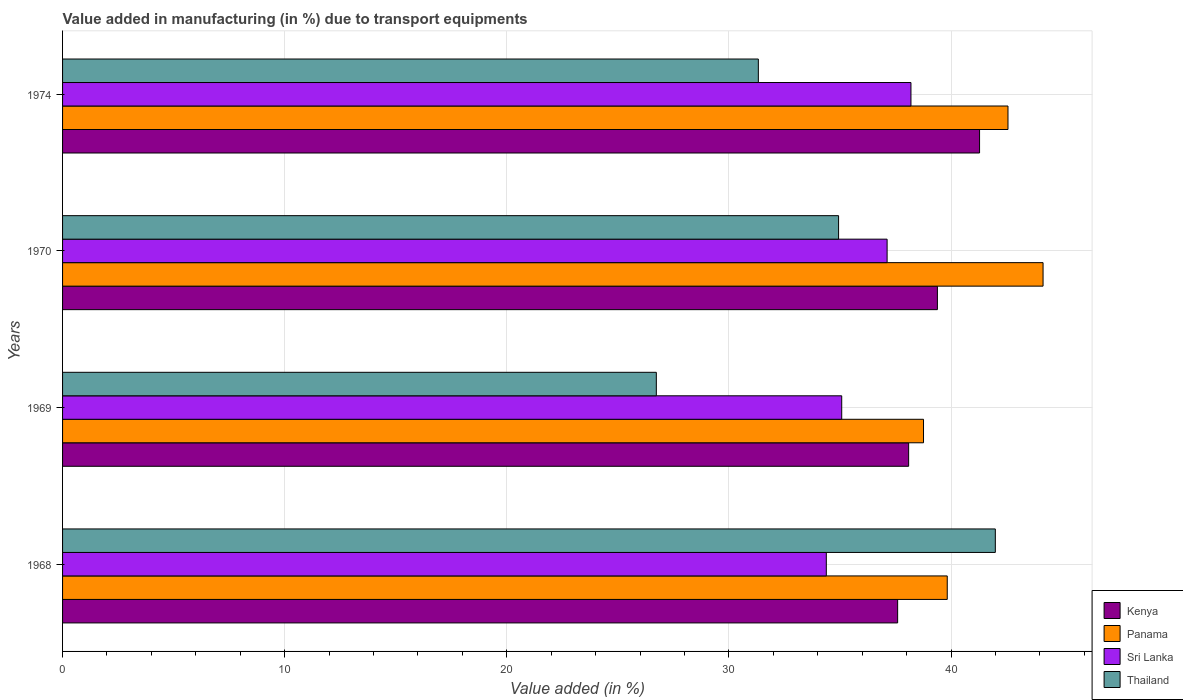How many different coloured bars are there?
Ensure brevity in your answer.  4. Are the number of bars per tick equal to the number of legend labels?
Offer a very short reply. Yes. Are the number of bars on each tick of the Y-axis equal?
Give a very brief answer. Yes. How many bars are there on the 1st tick from the top?
Give a very brief answer. 4. What is the label of the 4th group of bars from the top?
Make the answer very short. 1968. What is the percentage of value added in manufacturing due to transport equipments in Sri Lanka in 1969?
Your answer should be compact. 35.08. Across all years, what is the maximum percentage of value added in manufacturing due to transport equipments in Panama?
Offer a terse response. 44.14. Across all years, what is the minimum percentage of value added in manufacturing due to transport equipments in Thailand?
Keep it short and to the point. 26.73. In which year was the percentage of value added in manufacturing due to transport equipments in Panama maximum?
Offer a terse response. 1970. In which year was the percentage of value added in manufacturing due to transport equipments in Kenya minimum?
Offer a very short reply. 1968. What is the total percentage of value added in manufacturing due to transport equipments in Panama in the graph?
Your answer should be very brief. 165.3. What is the difference between the percentage of value added in manufacturing due to transport equipments in Panama in 1968 and that in 1970?
Give a very brief answer. -4.31. What is the difference between the percentage of value added in manufacturing due to transport equipments in Panama in 1970 and the percentage of value added in manufacturing due to transport equipments in Thailand in 1974?
Give a very brief answer. 12.82. What is the average percentage of value added in manufacturing due to transport equipments in Panama per year?
Your answer should be compact. 41.33. In the year 1969, what is the difference between the percentage of value added in manufacturing due to transport equipments in Sri Lanka and percentage of value added in manufacturing due to transport equipments in Panama?
Your response must be concise. -3.68. In how many years, is the percentage of value added in manufacturing due to transport equipments in Kenya greater than 42 %?
Ensure brevity in your answer.  0. What is the ratio of the percentage of value added in manufacturing due to transport equipments in Kenya in 1968 to that in 1969?
Ensure brevity in your answer.  0.99. Is the percentage of value added in manufacturing due to transport equipments in Kenya in 1970 less than that in 1974?
Your response must be concise. Yes. What is the difference between the highest and the second highest percentage of value added in manufacturing due to transport equipments in Panama?
Make the answer very short. 1.58. What is the difference between the highest and the lowest percentage of value added in manufacturing due to transport equipments in Sri Lanka?
Your answer should be compact. 3.81. In how many years, is the percentage of value added in manufacturing due to transport equipments in Kenya greater than the average percentage of value added in manufacturing due to transport equipments in Kenya taken over all years?
Your response must be concise. 2. Is the sum of the percentage of value added in manufacturing due to transport equipments in Thailand in 1968 and 1970 greater than the maximum percentage of value added in manufacturing due to transport equipments in Sri Lanka across all years?
Offer a very short reply. Yes. What does the 2nd bar from the top in 1970 represents?
Provide a short and direct response. Sri Lanka. What does the 4th bar from the bottom in 1970 represents?
Offer a terse response. Thailand. How many bars are there?
Your answer should be very brief. 16. Are all the bars in the graph horizontal?
Ensure brevity in your answer.  Yes. Does the graph contain any zero values?
Your answer should be compact. No. Where does the legend appear in the graph?
Your answer should be compact. Bottom right. How many legend labels are there?
Make the answer very short. 4. How are the legend labels stacked?
Make the answer very short. Vertical. What is the title of the graph?
Your answer should be very brief. Value added in manufacturing (in %) due to transport equipments. Does "Zimbabwe" appear as one of the legend labels in the graph?
Offer a terse response. No. What is the label or title of the X-axis?
Your answer should be compact. Value added (in %). What is the label or title of the Y-axis?
Your answer should be very brief. Years. What is the Value added (in %) of Kenya in 1968?
Provide a short and direct response. 37.6. What is the Value added (in %) of Panama in 1968?
Ensure brevity in your answer.  39.83. What is the Value added (in %) of Sri Lanka in 1968?
Your answer should be very brief. 34.39. What is the Value added (in %) in Thailand in 1968?
Offer a very short reply. 41.99. What is the Value added (in %) of Kenya in 1969?
Your response must be concise. 38.09. What is the Value added (in %) of Panama in 1969?
Your answer should be compact. 38.76. What is the Value added (in %) of Sri Lanka in 1969?
Ensure brevity in your answer.  35.08. What is the Value added (in %) in Thailand in 1969?
Give a very brief answer. 26.73. What is the Value added (in %) of Kenya in 1970?
Offer a very short reply. 39.39. What is the Value added (in %) in Panama in 1970?
Offer a terse response. 44.14. What is the Value added (in %) of Sri Lanka in 1970?
Give a very brief answer. 37.12. What is the Value added (in %) of Thailand in 1970?
Your answer should be very brief. 34.94. What is the Value added (in %) of Kenya in 1974?
Provide a short and direct response. 41.29. What is the Value added (in %) of Panama in 1974?
Provide a short and direct response. 42.56. What is the Value added (in %) of Sri Lanka in 1974?
Offer a very short reply. 38.2. What is the Value added (in %) of Thailand in 1974?
Your answer should be very brief. 31.33. Across all years, what is the maximum Value added (in %) in Kenya?
Keep it short and to the point. 41.29. Across all years, what is the maximum Value added (in %) of Panama?
Offer a very short reply. 44.14. Across all years, what is the maximum Value added (in %) of Sri Lanka?
Offer a very short reply. 38.2. Across all years, what is the maximum Value added (in %) in Thailand?
Ensure brevity in your answer.  41.99. Across all years, what is the minimum Value added (in %) in Kenya?
Provide a succinct answer. 37.6. Across all years, what is the minimum Value added (in %) of Panama?
Ensure brevity in your answer.  38.76. Across all years, what is the minimum Value added (in %) of Sri Lanka?
Ensure brevity in your answer.  34.39. Across all years, what is the minimum Value added (in %) of Thailand?
Offer a terse response. 26.73. What is the total Value added (in %) of Kenya in the graph?
Your response must be concise. 156.36. What is the total Value added (in %) in Panama in the graph?
Offer a very short reply. 165.3. What is the total Value added (in %) of Sri Lanka in the graph?
Make the answer very short. 144.78. What is the total Value added (in %) in Thailand in the graph?
Offer a very short reply. 134.99. What is the difference between the Value added (in %) in Kenya in 1968 and that in 1969?
Your response must be concise. -0.49. What is the difference between the Value added (in %) in Panama in 1968 and that in 1969?
Your answer should be very brief. 1.07. What is the difference between the Value added (in %) of Sri Lanka in 1968 and that in 1969?
Give a very brief answer. -0.69. What is the difference between the Value added (in %) in Thailand in 1968 and that in 1969?
Your answer should be very brief. 15.26. What is the difference between the Value added (in %) of Kenya in 1968 and that in 1970?
Ensure brevity in your answer.  -1.79. What is the difference between the Value added (in %) of Panama in 1968 and that in 1970?
Provide a succinct answer. -4.31. What is the difference between the Value added (in %) in Sri Lanka in 1968 and that in 1970?
Your answer should be very brief. -2.74. What is the difference between the Value added (in %) in Thailand in 1968 and that in 1970?
Your response must be concise. 7.06. What is the difference between the Value added (in %) of Kenya in 1968 and that in 1974?
Give a very brief answer. -3.69. What is the difference between the Value added (in %) in Panama in 1968 and that in 1974?
Your answer should be very brief. -2.73. What is the difference between the Value added (in %) in Sri Lanka in 1968 and that in 1974?
Your response must be concise. -3.81. What is the difference between the Value added (in %) of Thailand in 1968 and that in 1974?
Offer a terse response. 10.67. What is the difference between the Value added (in %) of Kenya in 1969 and that in 1970?
Ensure brevity in your answer.  -1.3. What is the difference between the Value added (in %) of Panama in 1969 and that in 1970?
Give a very brief answer. -5.38. What is the difference between the Value added (in %) of Sri Lanka in 1969 and that in 1970?
Provide a succinct answer. -2.04. What is the difference between the Value added (in %) in Thailand in 1969 and that in 1970?
Ensure brevity in your answer.  -8.21. What is the difference between the Value added (in %) of Kenya in 1969 and that in 1974?
Make the answer very short. -3.19. What is the difference between the Value added (in %) of Panama in 1969 and that in 1974?
Ensure brevity in your answer.  -3.8. What is the difference between the Value added (in %) in Sri Lanka in 1969 and that in 1974?
Your answer should be very brief. -3.12. What is the difference between the Value added (in %) of Thailand in 1969 and that in 1974?
Provide a short and direct response. -4.59. What is the difference between the Value added (in %) of Kenya in 1970 and that in 1974?
Offer a very short reply. -1.9. What is the difference between the Value added (in %) in Panama in 1970 and that in 1974?
Offer a terse response. 1.58. What is the difference between the Value added (in %) in Sri Lanka in 1970 and that in 1974?
Make the answer very short. -1.07. What is the difference between the Value added (in %) in Thailand in 1970 and that in 1974?
Your response must be concise. 3.61. What is the difference between the Value added (in %) in Kenya in 1968 and the Value added (in %) in Panama in 1969?
Give a very brief answer. -1.16. What is the difference between the Value added (in %) in Kenya in 1968 and the Value added (in %) in Sri Lanka in 1969?
Keep it short and to the point. 2.52. What is the difference between the Value added (in %) in Kenya in 1968 and the Value added (in %) in Thailand in 1969?
Your answer should be compact. 10.87. What is the difference between the Value added (in %) in Panama in 1968 and the Value added (in %) in Sri Lanka in 1969?
Keep it short and to the point. 4.75. What is the difference between the Value added (in %) in Panama in 1968 and the Value added (in %) in Thailand in 1969?
Provide a short and direct response. 13.1. What is the difference between the Value added (in %) in Sri Lanka in 1968 and the Value added (in %) in Thailand in 1969?
Provide a short and direct response. 7.65. What is the difference between the Value added (in %) in Kenya in 1968 and the Value added (in %) in Panama in 1970?
Keep it short and to the point. -6.55. What is the difference between the Value added (in %) in Kenya in 1968 and the Value added (in %) in Sri Lanka in 1970?
Offer a very short reply. 0.47. What is the difference between the Value added (in %) of Kenya in 1968 and the Value added (in %) of Thailand in 1970?
Offer a very short reply. 2.66. What is the difference between the Value added (in %) of Panama in 1968 and the Value added (in %) of Sri Lanka in 1970?
Your response must be concise. 2.71. What is the difference between the Value added (in %) in Panama in 1968 and the Value added (in %) in Thailand in 1970?
Provide a short and direct response. 4.89. What is the difference between the Value added (in %) of Sri Lanka in 1968 and the Value added (in %) of Thailand in 1970?
Offer a terse response. -0.55. What is the difference between the Value added (in %) in Kenya in 1968 and the Value added (in %) in Panama in 1974?
Give a very brief answer. -4.97. What is the difference between the Value added (in %) in Kenya in 1968 and the Value added (in %) in Sri Lanka in 1974?
Make the answer very short. -0.6. What is the difference between the Value added (in %) of Kenya in 1968 and the Value added (in %) of Thailand in 1974?
Keep it short and to the point. 6.27. What is the difference between the Value added (in %) in Panama in 1968 and the Value added (in %) in Sri Lanka in 1974?
Provide a succinct answer. 1.63. What is the difference between the Value added (in %) of Panama in 1968 and the Value added (in %) of Thailand in 1974?
Ensure brevity in your answer.  8.51. What is the difference between the Value added (in %) in Sri Lanka in 1968 and the Value added (in %) in Thailand in 1974?
Your response must be concise. 3.06. What is the difference between the Value added (in %) of Kenya in 1969 and the Value added (in %) of Panama in 1970?
Your answer should be compact. -6.05. What is the difference between the Value added (in %) of Kenya in 1969 and the Value added (in %) of Sri Lanka in 1970?
Offer a terse response. 0.97. What is the difference between the Value added (in %) of Kenya in 1969 and the Value added (in %) of Thailand in 1970?
Give a very brief answer. 3.15. What is the difference between the Value added (in %) of Panama in 1969 and the Value added (in %) of Sri Lanka in 1970?
Your answer should be compact. 1.64. What is the difference between the Value added (in %) of Panama in 1969 and the Value added (in %) of Thailand in 1970?
Provide a short and direct response. 3.82. What is the difference between the Value added (in %) of Sri Lanka in 1969 and the Value added (in %) of Thailand in 1970?
Your response must be concise. 0.14. What is the difference between the Value added (in %) in Kenya in 1969 and the Value added (in %) in Panama in 1974?
Ensure brevity in your answer.  -4.47. What is the difference between the Value added (in %) in Kenya in 1969 and the Value added (in %) in Sri Lanka in 1974?
Offer a terse response. -0.1. What is the difference between the Value added (in %) of Kenya in 1969 and the Value added (in %) of Thailand in 1974?
Your answer should be very brief. 6.77. What is the difference between the Value added (in %) of Panama in 1969 and the Value added (in %) of Sri Lanka in 1974?
Offer a terse response. 0.57. What is the difference between the Value added (in %) in Panama in 1969 and the Value added (in %) in Thailand in 1974?
Your response must be concise. 7.44. What is the difference between the Value added (in %) in Sri Lanka in 1969 and the Value added (in %) in Thailand in 1974?
Your answer should be very brief. 3.75. What is the difference between the Value added (in %) in Kenya in 1970 and the Value added (in %) in Panama in 1974?
Ensure brevity in your answer.  -3.18. What is the difference between the Value added (in %) in Kenya in 1970 and the Value added (in %) in Sri Lanka in 1974?
Make the answer very short. 1.19. What is the difference between the Value added (in %) of Kenya in 1970 and the Value added (in %) of Thailand in 1974?
Provide a succinct answer. 8.06. What is the difference between the Value added (in %) of Panama in 1970 and the Value added (in %) of Sri Lanka in 1974?
Provide a succinct answer. 5.95. What is the difference between the Value added (in %) of Panama in 1970 and the Value added (in %) of Thailand in 1974?
Your answer should be compact. 12.82. What is the difference between the Value added (in %) of Sri Lanka in 1970 and the Value added (in %) of Thailand in 1974?
Offer a very short reply. 5.8. What is the average Value added (in %) of Kenya per year?
Make the answer very short. 39.09. What is the average Value added (in %) of Panama per year?
Your answer should be compact. 41.33. What is the average Value added (in %) of Sri Lanka per year?
Your response must be concise. 36.2. What is the average Value added (in %) in Thailand per year?
Keep it short and to the point. 33.75. In the year 1968, what is the difference between the Value added (in %) in Kenya and Value added (in %) in Panama?
Your answer should be very brief. -2.23. In the year 1968, what is the difference between the Value added (in %) in Kenya and Value added (in %) in Sri Lanka?
Ensure brevity in your answer.  3.21. In the year 1968, what is the difference between the Value added (in %) of Kenya and Value added (in %) of Thailand?
Ensure brevity in your answer.  -4.4. In the year 1968, what is the difference between the Value added (in %) of Panama and Value added (in %) of Sri Lanka?
Make the answer very short. 5.45. In the year 1968, what is the difference between the Value added (in %) of Panama and Value added (in %) of Thailand?
Provide a short and direct response. -2.16. In the year 1968, what is the difference between the Value added (in %) of Sri Lanka and Value added (in %) of Thailand?
Offer a very short reply. -7.61. In the year 1969, what is the difference between the Value added (in %) in Kenya and Value added (in %) in Panama?
Provide a succinct answer. -0.67. In the year 1969, what is the difference between the Value added (in %) of Kenya and Value added (in %) of Sri Lanka?
Offer a terse response. 3.01. In the year 1969, what is the difference between the Value added (in %) in Kenya and Value added (in %) in Thailand?
Your response must be concise. 11.36. In the year 1969, what is the difference between the Value added (in %) of Panama and Value added (in %) of Sri Lanka?
Your answer should be compact. 3.68. In the year 1969, what is the difference between the Value added (in %) of Panama and Value added (in %) of Thailand?
Give a very brief answer. 12.03. In the year 1969, what is the difference between the Value added (in %) in Sri Lanka and Value added (in %) in Thailand?
Offer a terse response. 8.35. In the year 1970, what is the difference between the Value added (in %) in Kenya and Value added (in %) in Panama?
Provide a short and direct response. -4.76. In the year 1970, what is the difference between the Value added (in %) of Kenya and Value added (in %) of Sri Lanka?
Offer a very short reply. 2.26. In the year 1970, what is the difference between the Value added (in %) in Kenya and Value added (in %) in Thailand?
Provide a short and direct response. 4.45. In the year 1970, what is the difference between the Value added (in %) of Panama and Value added (in %) of Sri Lanka?
Your response must be concise. 7.02. In the year 1970, what is the difference between the Value added (in %) of Panama and Value added (in %) of Thailand?
Your response must be concise. 9.21. In the year 1970, what is the difference between the Value added (in %) in Sri Lanka and Value added (in %) in Thailand?
Provide a short and direct response. 2.19. In the year 1974, what is the difference between the Value added (in %) in Kenya and Value added (in %) in Panama?
Make the answer very short. -1.28. In the year 1974, what is the difference between the Value added (in %) in Kenya and Value added (in %) in Sri Lanka?
Offer a terse response. 3.09. In the year 1974, what is the difference between the Value added (in %) of Kenya and Value added (in %) of Thailand?
Provide a short and direct response. 9.96. In the year 1974, what is the difference between the Value added (in %) in Panama and Value added (in %) in Sri Lanka?
Your answer should be compact. 4.37. In the year 1974, what is the difference between the Value added (in %) in Panama and Value added (in %) in Thailand?
Ensure brevity in your answer.  11.24. In the year 1974, what is the difference between the Value added (in %) in Sri Lanka and Value added (in %) in Thailand?
Make the answer very short. 6.87. What is the ratio of the Value added (in %) in Panama in 1968 to that in 1969?
Keep it short and to the point. 1.03. What is the ratio of the Value added (in %) of Sri Lanka in 1968 to that in 1969?
Give a very brief answer. 0.98. What is the ratio of the Value added (in %) of Thailand in 1968 to that in 1969?
Give a very brief answer. 1.57. What is the ratio of the Value added (in %) of Kenya in 1968 to that in 1970?
Give a very brief answer. 0.95. What is the ratio of the Value added (in %) of Panama in 1968 to that in 1970?
Your answer should be very brief. 0.9. What is the ratio of the Value added (in %) of Sri Lanka in 1968 to that in 1970?
Make the answer very short. 0.93. What is the ratio of the Value added (in %) of Thailand in 1968 to that in 1970?
Provide a succinct answer. 1.2. What is the ratio of the Value added (in %) of Kenya in 1968 to that in 1974?
Your answer should be compact. 0.91. What is the ratio of the Value added (in %) in Panama in 1968 to that in 1974?
Ensure brevity in your answer.  0.94. What is the ratio of the Value added (in %) in Sri Lanka in 1968 to that in 1974?
Your response must be concise. 0.9. What is the ratio of the Value added (in %) of Thailand in 1968 to that in 1974?
Make the answer very short. 1.34. What is the ratio of the Value added (in %) of Kenya in 1969 to that in 1970?
Offer a very short reply. 0.97. What is the ratio of the Value added (in %) of Panama in 1969 to that in 1970?
Offer a terse response. 0.88. What is the ratio of the Value added (in %) in Sri Lanka in 1969 to that in 1970?
Ensure brevity in your answer.  0.94. What is the ratio of the Value added (in %) of Thailand in 1969 to that in 1970?
Your answer should be very brief. 0.77. What is the ratio of the Value added (in %) in Kenya in 1969 to that in 1974?
Offer a very short reply. 0.92. What is the ratio of the Value added (in %) of Panama in 1969 to that in 1974?
Make the answer very short. 0.91. What is the ratio of the Value added (in %) in Sri Lanka in 1969 to that in 1974?
Give a very brief answer. 0.92. What is the ratio of the Value added (in %) in Thailand in 1969 to that in 1974?
Offer a terse response. 0.85. What is the ratio of the Value added (in %) in Kenya in 1970 to that in 1974?
Offer a terse response. 0.95. What is the ratio of the Value added (in %) of Panama in 1970 to that in 1974?
Ensure brevity in your answer.  1.04. What is the ratio of the Value added (in %) of Sri Lanka in 1970 to that in 1974?
Provide a short and direct response. 0.97. What is the ratio of the Value added (in %) in Thailand in 1970 to that in 1974?
Make the answer very short. 1.12. What is the difference between the highest and the second highest Value added (in %) in Kenya?
Your answer should be very brief. 1.9. What is the difference between the highest and the second highest Value added (in %) of Panama?
Provide a succinct answer. 1.58. What is the difference between the highest and the second highest Value added (in %) in Sri Lanka?
Make the answer very short. 1.07. What is the difference between the highest and the second highest Value added (in %) in Thailand?
Your answer should be compact. 7.06. What is the difference between the highest and the lowest Value added (in %) of Kenya?
Your response must be concise. 3.69. What is the difference between the highest and the lowest Value added (in %) of Panama?
Your answer should be very brief. 5.38. What is the difference between the highest and the lowest Value added (in %) of Sri Lanka?
Ensure brevity in your answer.  3.81. What is the difference between the highest and the lowest Value added (in %) in Thailand?
Offer a terse response. 15.26. 